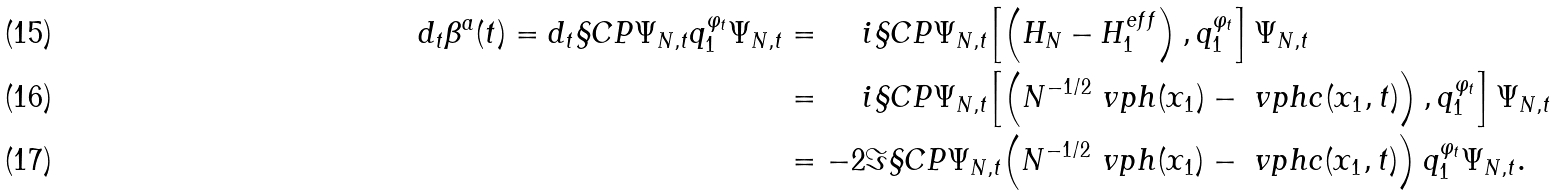<formula> <loc_0><loc_0><loc_500><loc_500>d _ { t } \beta ^ { a } ( t ) = d _ { t } \S C P { \Psi _ { N , t } } { q _ { 1 } ^ { \varphi _ { t } } \Psi _ { N , t } } & = \quad \, i \S C P { \Psi _ { N , t } } { \left [ \left ( H _ { N } - H _ { 1 } ^ { e f f } \right ) , q _ { 1 } ^ { \varphi _ { t } } \right ] \Psi _ { N , t } } \\ & = \quad \, i \S C P { \Psi _ { N , t } } { \left [ \left ( N ^ { - 1 / 2 } \ v p h ( x _ { 1 } ) - \ v p h c ( x _ { 1 } , t ) \right ) , q _ { 1 } ^ { \varphi _ { t } } \right ] \Psi _ { N , t } } \\ & = - 2 \Im \S C P { \Psi _ { N , t } } { \left ( N ^ { - 1 / 2 } \ v p h ( x _ { 1 } ) - \ v p h c ( x _ { 1 } , t ) \right ) q _ { 1 } ^ { \varphi _ { t } } \Psi _ { N , t } } .</formula> 